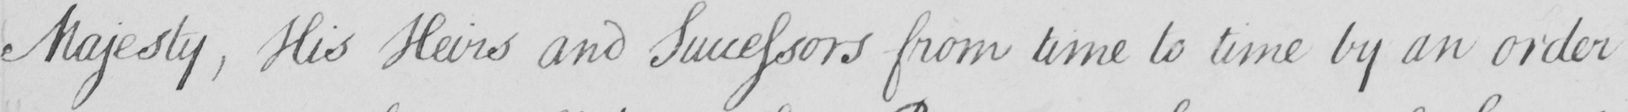Can you tell me what this handwritten text says? Majesty , His Heirs and Successors from time to time by an order 